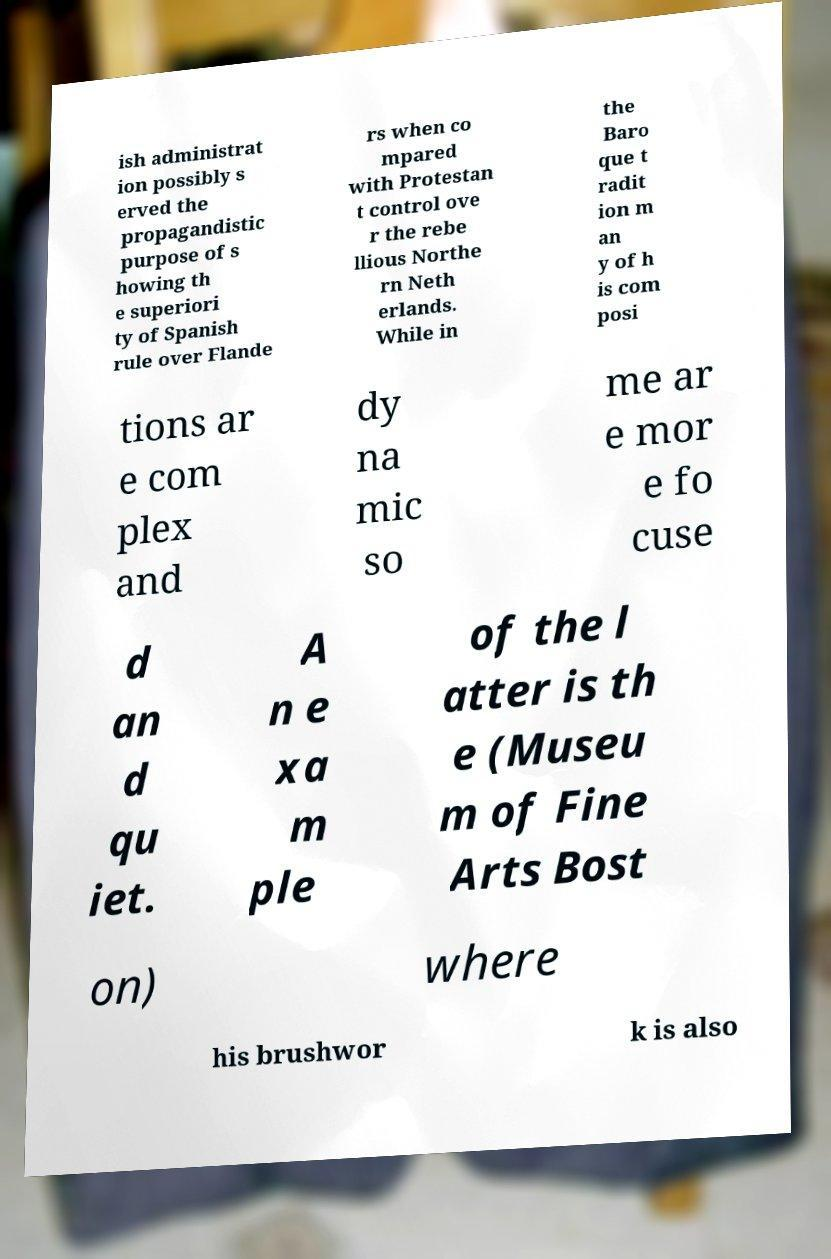Can you accurately transcribe the text from the provided image for me? ish administrat ion possibly s erved the propagandistic purpose of s howing th e superiori ty of Spanish rule over Flande rs when co mpared with Protestan t control ove r the rebe llious Northe rn Neth erlands. While in the Baro que t radit ion m an y of h is com posi tions ar e com plex and dy na mic so me ar e mor e fo cuse d an d qu iet. A n e xa m ple of the l atter is th e (Museu m of Fine Arts Bost on) where his brushwor k is also 